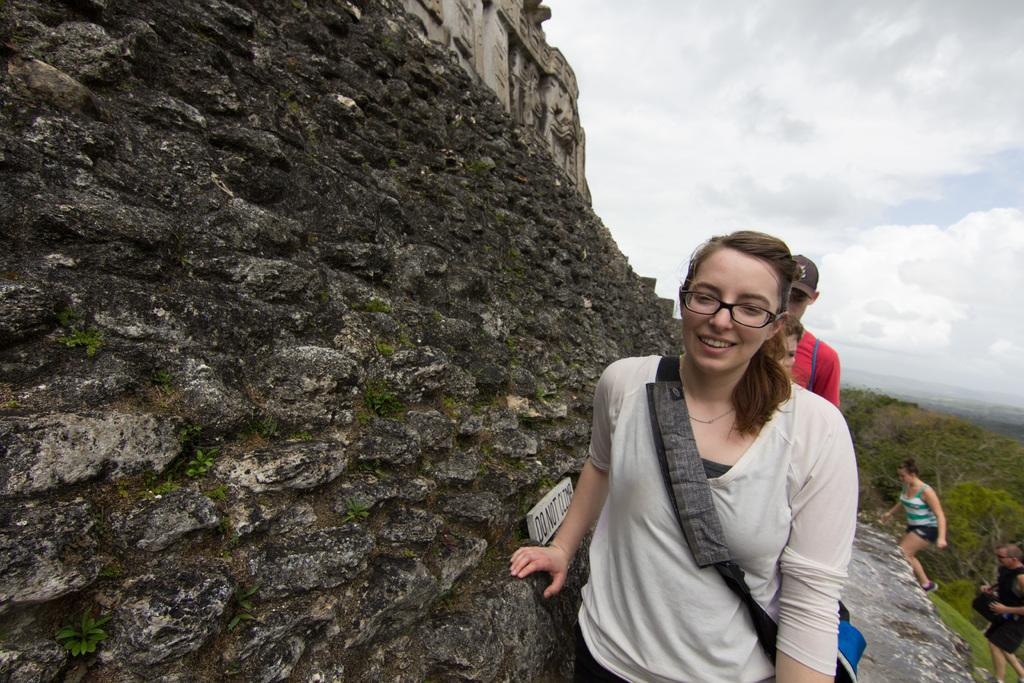Who is the main subject in the foreground of the image? There is a woman in the foreground of the image. What accessory is the woman wearing in the image? The woman is wearing glasses in the image. What activity is taking place in the background of the image? There are people climbing a mountain in the background of the image. What type of store can be seen in the image? There is no store present in the image. What month is it in the image? The month cannot be determined from the image. 